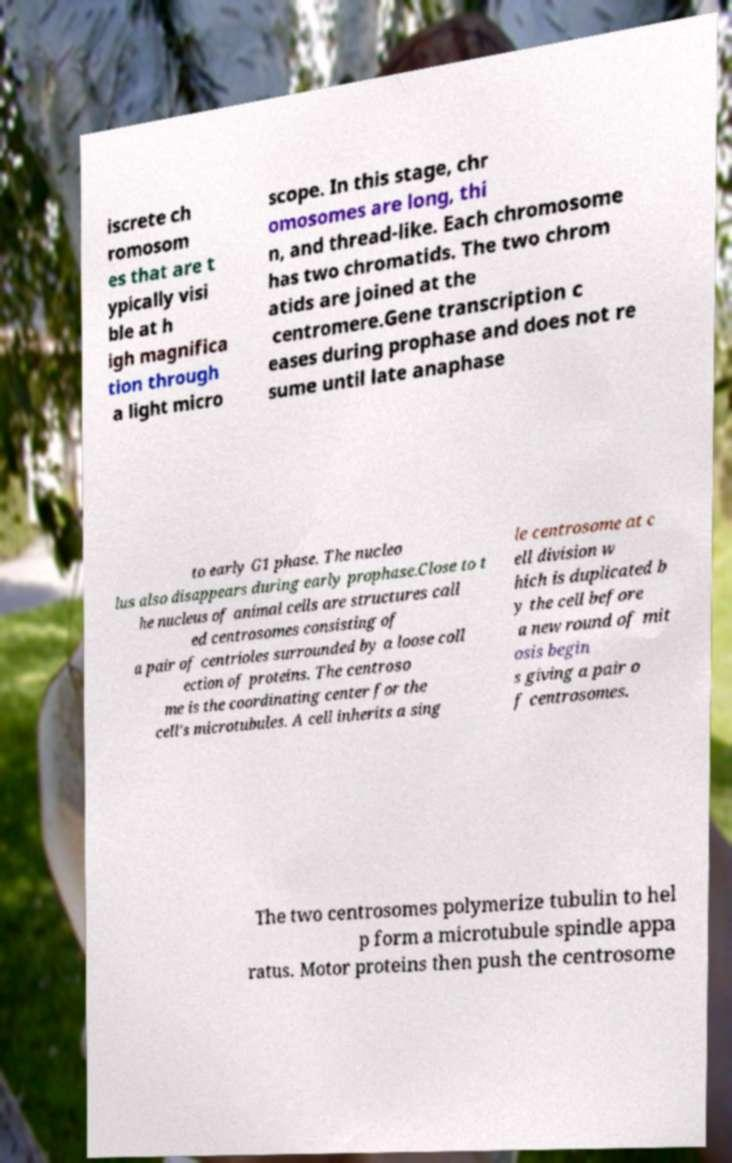There's text embedded in this image that I need extracted. Can you transcribe it verbatim? iscrete ch romosom es that are t ypically visi ble at h igh magnifica tion through a light micro scope. In this stage, chr omosomes are long, thi n, and thread-like. Each chromosome has two chromatids. The two chrom atids are joined at the centromere.Gene transcription c eases during prophase and does not re sume until late anaphase to early G1 phase. The nucleo lus also disappears during early prophase.Close to t he nucleus of animal cells are structures call ed centrosomes consisting of a pair of centrioles surrounded by a loose coll ection of proteins. The centroso me is the coordinating center for the cell's microtubules. A cell inherits a sing le centrosome at c ell division w hich is duplicated b y the cell before a new round of mit osis begin s giving a pair o f centrosomes. The two centrosomes polymerize tubulin to hel p form a microtubule spindle appa ratus. Motor proteins then push the centrosome 